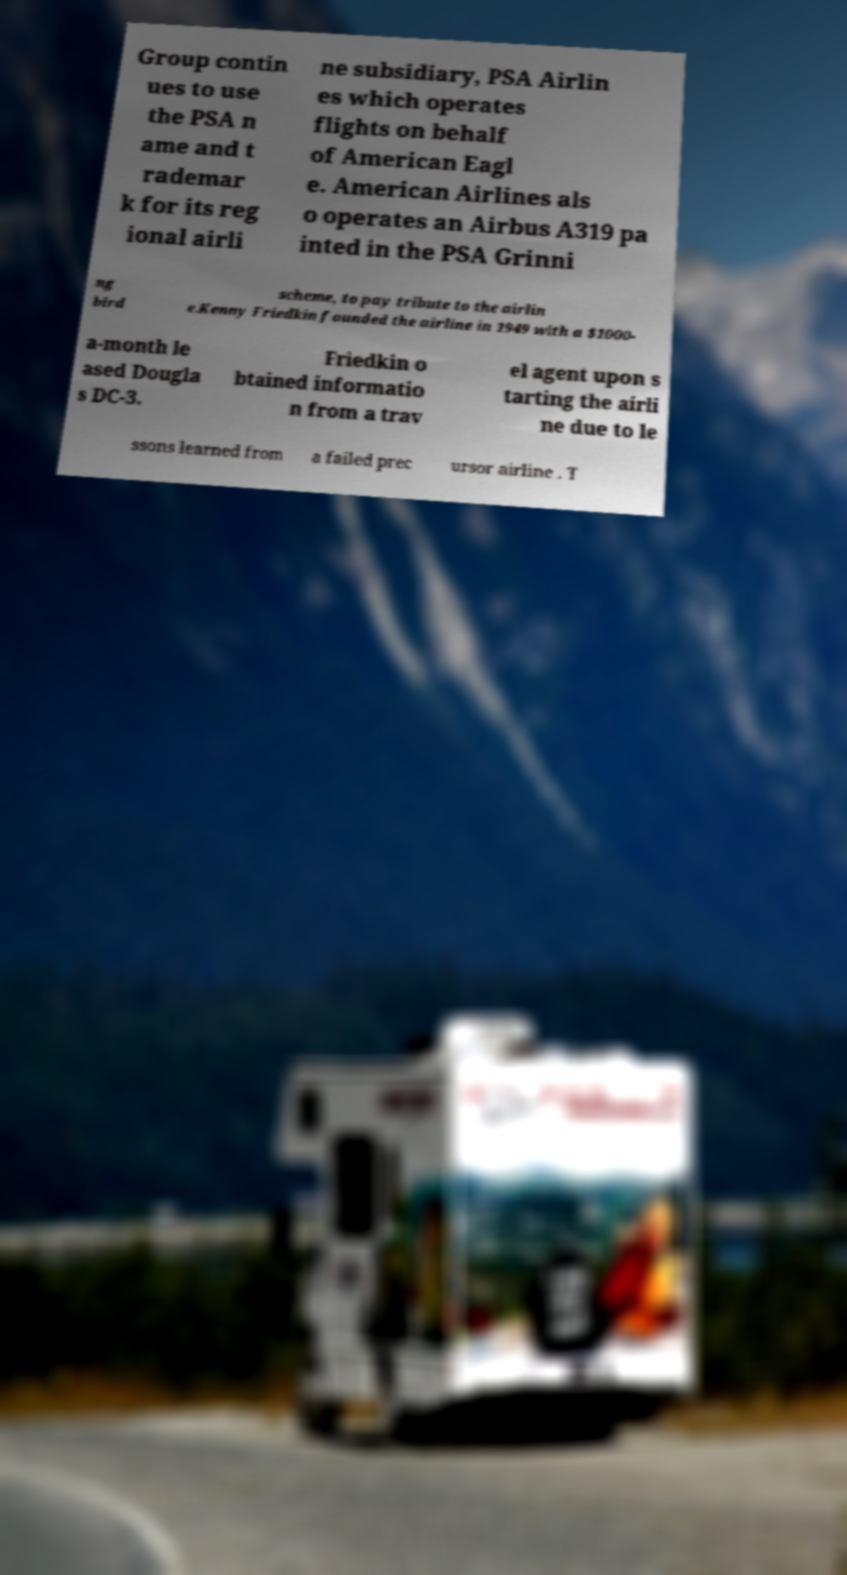Can you accurately transcribe the text from the provided image for me? Group contin ues to use the PSA n ame and t rademar k for its reg ional airli ne subsidiary, PSA Airlin es which operates flights on behalf of American Eagl e. American Airlines als o operates an Airbus A319 pa inted in the PSA Grinni ng bird scheme, to pay tribute to the airlin e.Kenny Friedkin founded the airline in 1949 with a $1000- a-month le ased Dougla s DC-3. Friedkin o btained informatio n from a trav el agent upon s tarting the airli ne due to le ssons learned from a failed prec ursor airline . T 